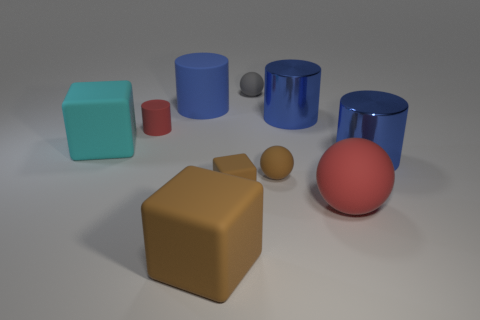What number of things are red things that are on the left side of the tiny gray thing or large matte things behind the large brown matte block?
Make the answer very short. 4. How many objects are either big brown things or rubber spheres that are left of the big red ball?
Provide a succinct answer. 3. There is a red rubber object to the right of the ball behind the blue cylinder on the left side of the brown matte sphere; what size is it?
Your response must be concise. Large. What material is the red sphere that is the same size as the cyan cube?
Ensure brevity in your answer.  Rubber. Are there any red objects that have the same size as the cyan block?
Offer a very short reply. Yes. There is a blue thing that is left of the gray matte object; does it have the same size as the small brown block?
Offer a terse response. No. What shape is the big rubber object that is both on the right side of the large cyan rubber cube and behind the red matte ball?
Offer a terse response. Cylinder. Is the number of small cylinders behind the tiny cube greater than the number of big cyan blocks?
Your response must be concise. No. There is a cyan cube that is made of the same material as the gray ball; what is its size?
Provide a short and direct response. Large. How many large metallic cylinders have the same color as the small cube?
Offer a very short reply. 0. 